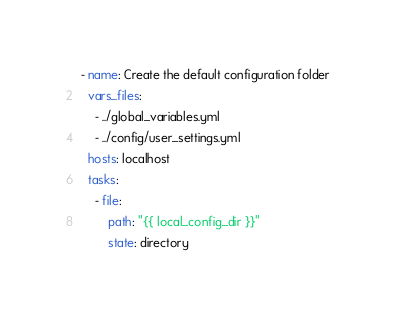<code> <loc_0><loc_0><loc_500><loc_500><_YAML_>- name: Create the default configuration folder
  vars_files:
    - ../global_variables.yml
    - ../config/user_settings.yml
  hosts: localhost
  tasks:
    - file:
        path: "{{ local_config_dir }}"
        state: directory
</code> 